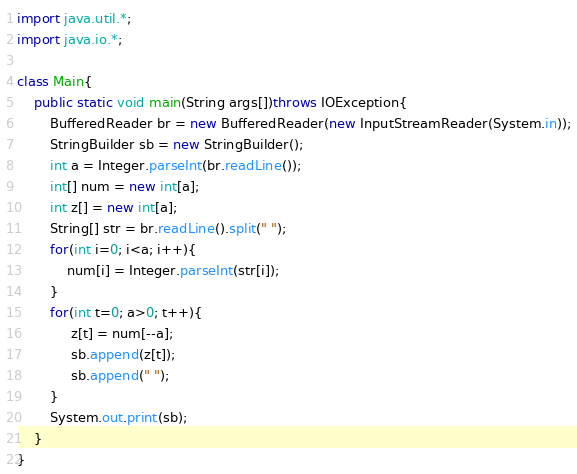<code> <loc_0><loc_0><loc_500><loc_500><_Java_>import java.util.*;
import java.io.*;

class Main{
    public static void main(String args[])throws IOException{
        BufferedReader br = new BufferedReader(new InputStreamReader(System.in));
        StringBuilder sb = new StringBuilder();
        int a = Integer.parseInt(br.readLine());
        int[] num = new int[a];
        int z[] = new int[a];
        String[] str = br.readLine().split(" ");
        for(int i=0; i<a; i++){
            num[i] = Integer.parseInt(str[i]);
        }
        for(int t=0; a>0; t++){
             z[t] = num[--a];
             sb.append(z[t]);
             sb.append(" ");
        }
        System.out.print(sb);
    }
}</code> 